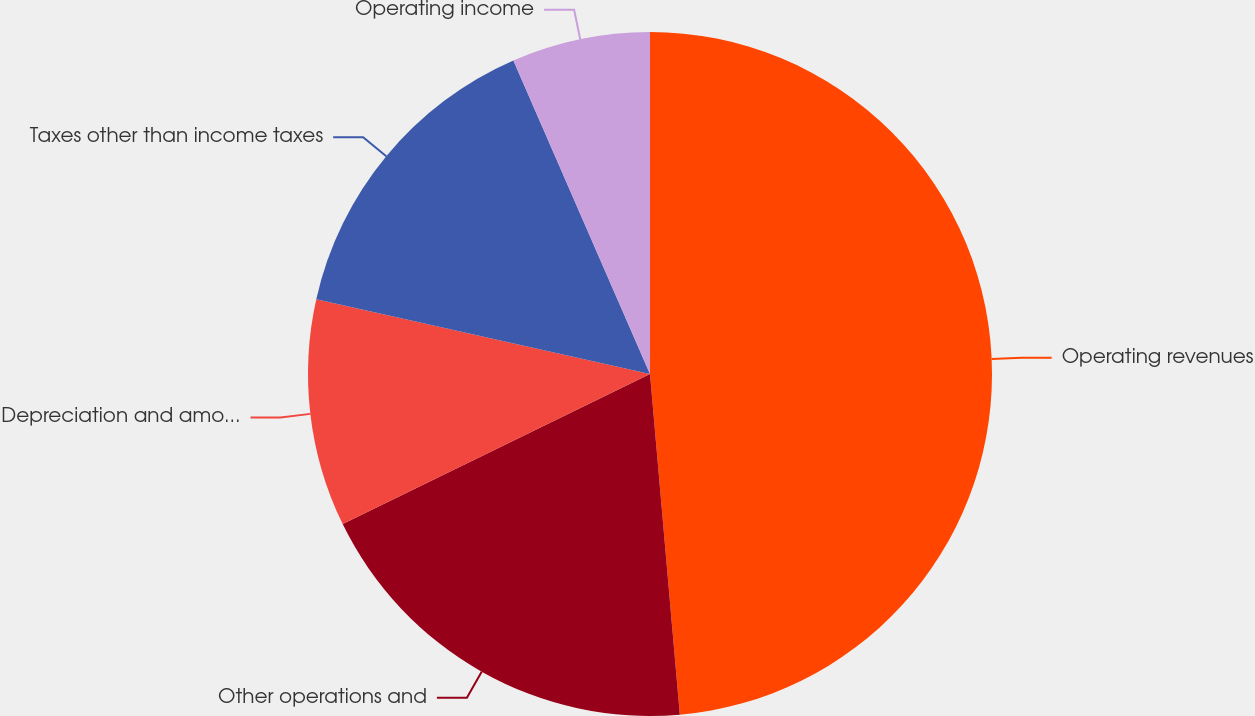Convert chart to OTSL. <chart><loc_0><loc_0><loc_500><loc_500><pie_chart><fcel>Operating revenues<fcel>Other operations and<fcel>Depreciation and amortization<fcel>Taxes other than income taxes<fcel>Operating income<nl><fcel>48.61%<fcel>19.16%<fcel>10.74%<fcel>14.95%<fcel>6.54%<nl></chart> 